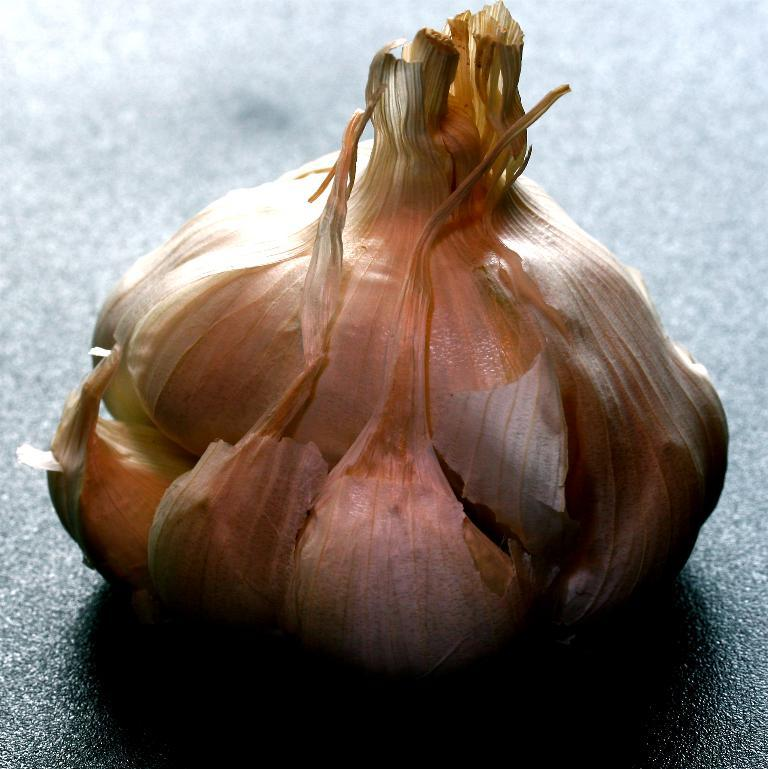What is the main subject of the image? The main subject of the image is a garlic. Where is the garlic located in the image? The garlic is placed on a surface in the image. What statement does the garlic make in the image? The garlic does not make a statement in the image; it is an inanimate object. 